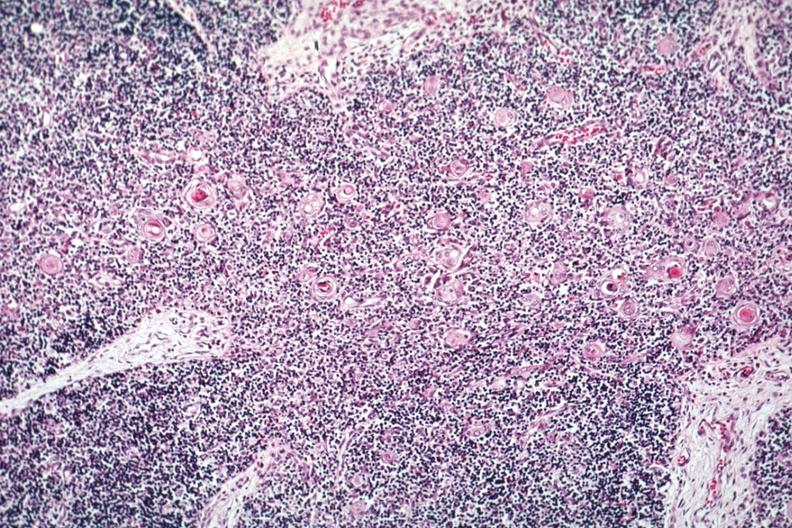s normal immature infant present?
Answer the question using a single word or phrase. Yes 